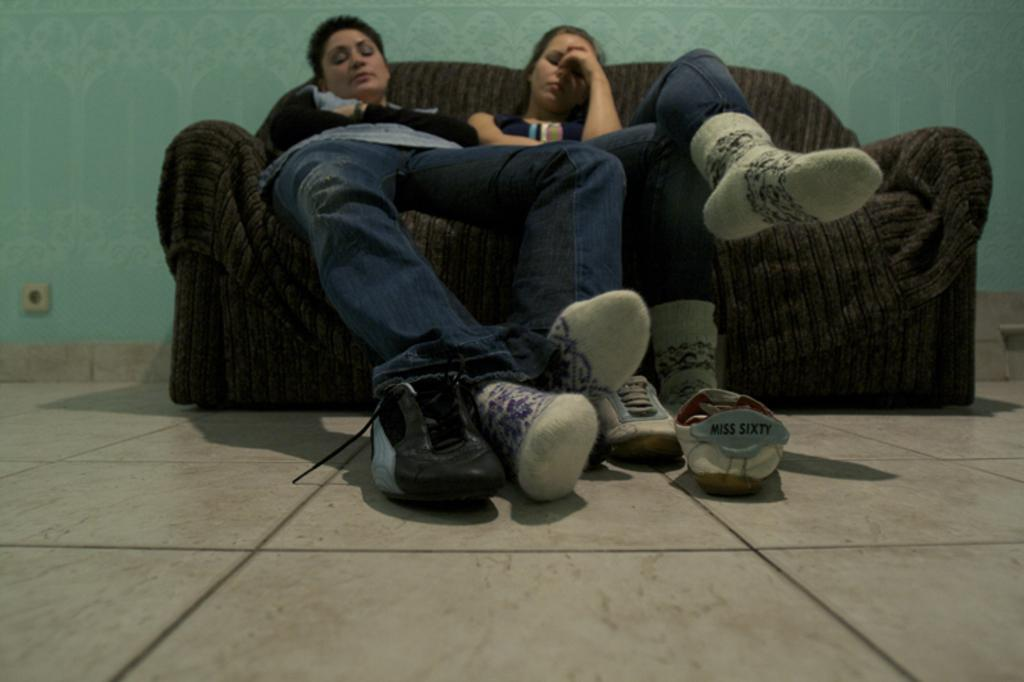How many people are sitting on the sofa in the image? There are two persons sitting on the sofa in the image. What else can be seen in the image besides the sofa and the people sitting on it? Shoes are visible in the image. What is visible in the background of the image? There is a wall in the background of the image. What type of sugar can be seen in the image? There is no sugar present in the image. How many women are visible in the image? The image does not specify the gender of the two persons sitting on the sofa, so we cannot determine if they are women or not. Is there a harbor visible in the image? There is no harbor present in the image. 